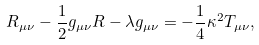Convert formula to latex. <formula><loc_0><loc_0><loc_500><loc_500>R _ { \mu \nu } - \frac { 1 } { 2 } g _ { \mu \nu } R - \lambda g _ { \mu \nu } = - \frac { 1 } { 4 } \kappa ^ { 2 } T _ { \mu \nu } ,</formula> 